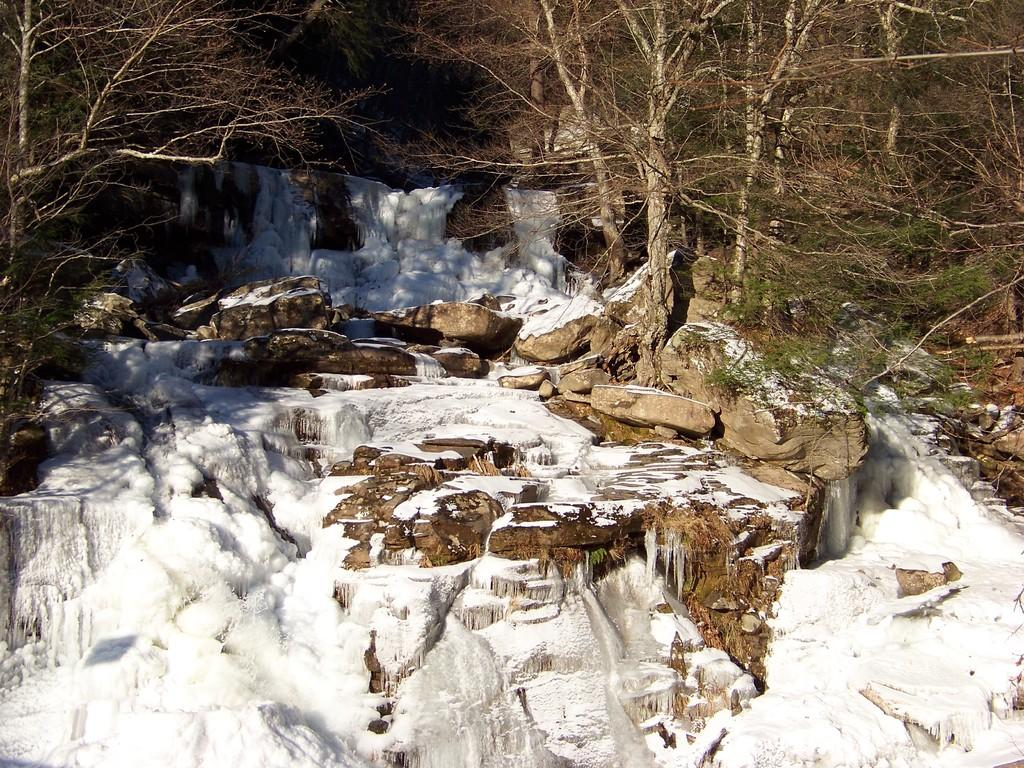What type of weather condition is depicted in the image? There is snow in the image, indicating a cold and wintry scene. What natural elements can be seen in the image? There are rocks, trees, and snow visible in the image. How many types of natural elements are present in the image? There are three types of natural elements present in the image: rocks, trees, and snow. What type of birthday celebration is taking place in the image? There is no indication of a birthday celebration in the image; it features snow, rocks, and trees. How does the glove help with the health of the trees in the image? There is no glove present in the image, and therefore no impact on the health of the trees can be determined. 